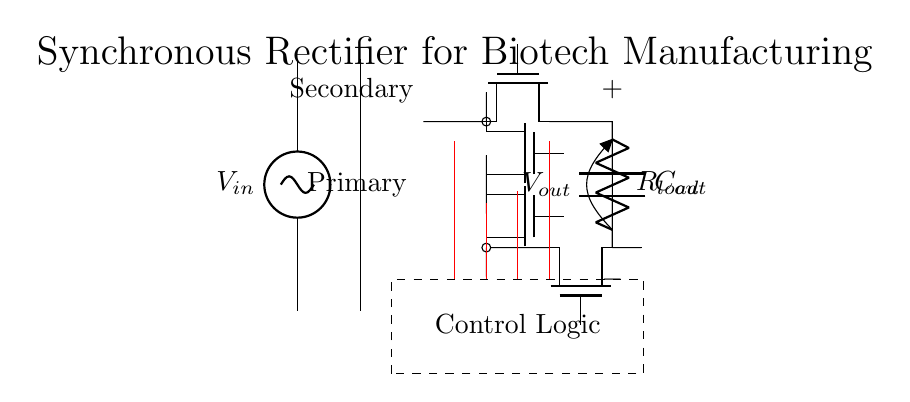What component is used as the input source? The circuit uses a voltage source labeled as V_in at the input side. This is the starting point for the circuit which supplies alternating current.
Answer: V_in How many Tnmos transistors are present in the circuit? The circuit diagram shows four Tnmos transistors marked as M1, M2, M3, and M4. These are the active components used for rectification.
Answer: Four What is the purpose of the capacitor in this circuit? The capacitor, labeled C_out, is used to smooth the output voltage and provide energy storage to maintain the output during load variations, thus filtering out ripples.
Answer: Smoothing What type of rectifier is represented in this diagram? The circuit is a synchronous rectifier, which uses transistors to rectify current more efficiently compared to traditional diodes, reducing losses during operation.
Answer: Synchronous What does the dashed rectangle represent? The dashed rectangle encloses the control logic, indicating that it manages the operation of the Tnmos transistors to ensure efficient rectification as per the input AC signal.
Answer: Control Logic How is the output voltage labeled in the circuit? The output voltage is labeled as V_out, which indicates the voltage available across the load resistor and capacitor at the output end of the rectifier circuit.
Answer: V_out What is the load connected to in the circuit? The load is represented as R_load, which is connected to the output side. This resistor represents the device or circuit consuming power from the rectifier output.
Answer: R_load 